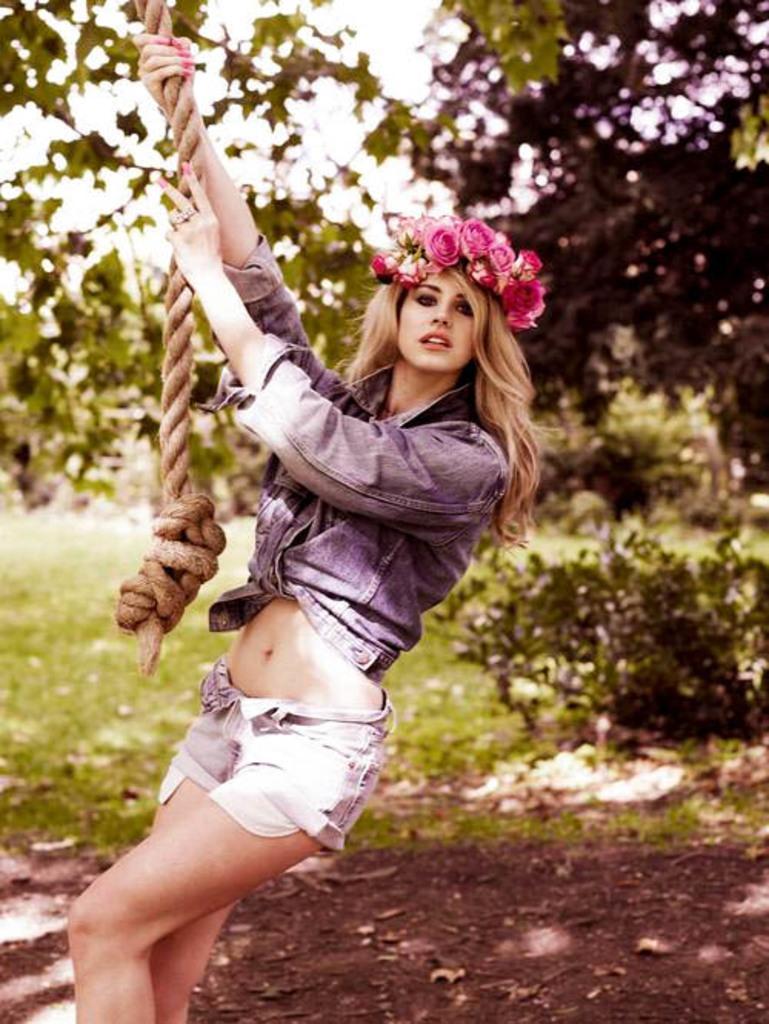Describe this image in one or two sentences. In the foreground of the picture there is a woman holding a rope and there is mud. In the background there are trees, plants and grass. 